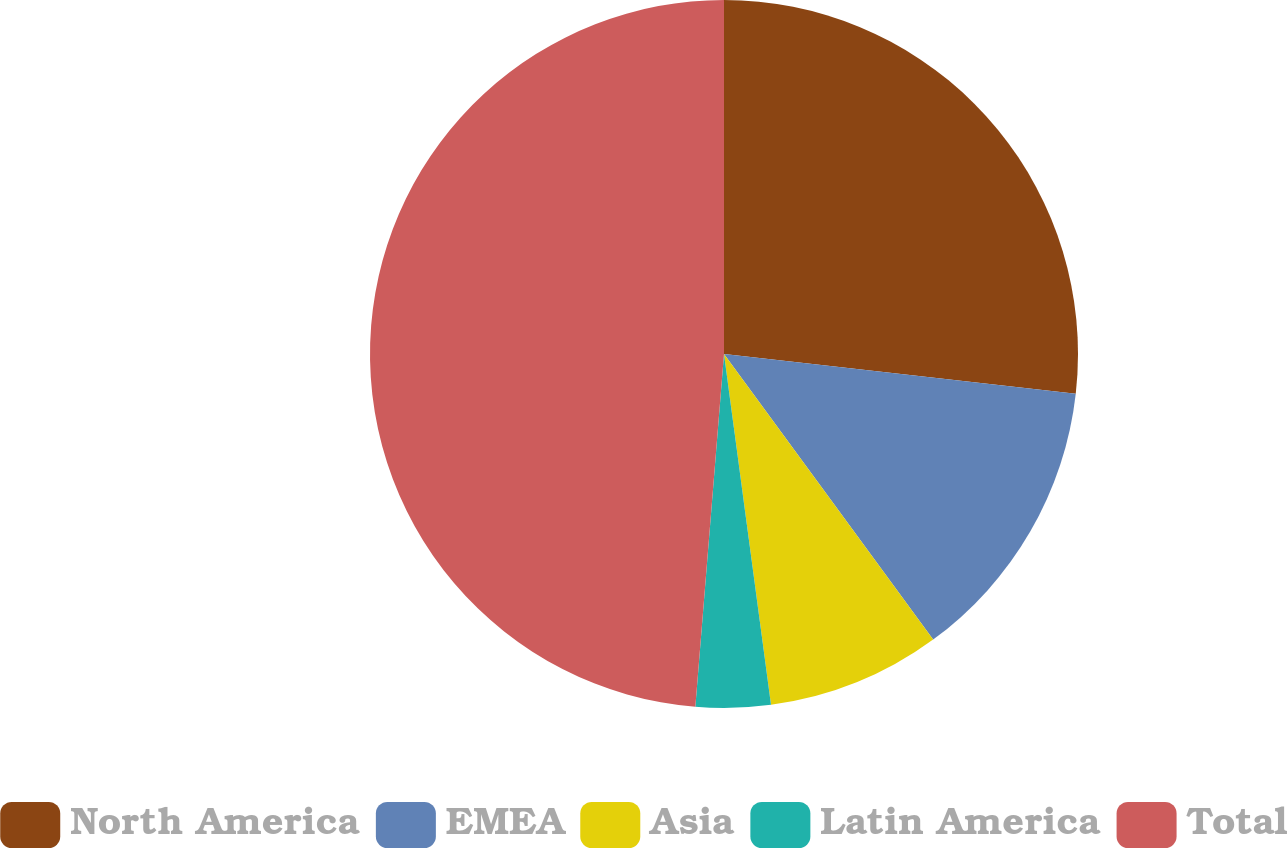Convert chart to OTSL. <chart><loc_0><loc_0><loc_500><loc_500><pie_chart><fcel>North America<fcel>EMEA<fcel>Asia<fcel>Latin America<fcel>Total<nl><fcel>26.79%<fcel>13.15%<fcel>7.94%<fcel>3.41%<fcel>48.71%<nl></chart> 